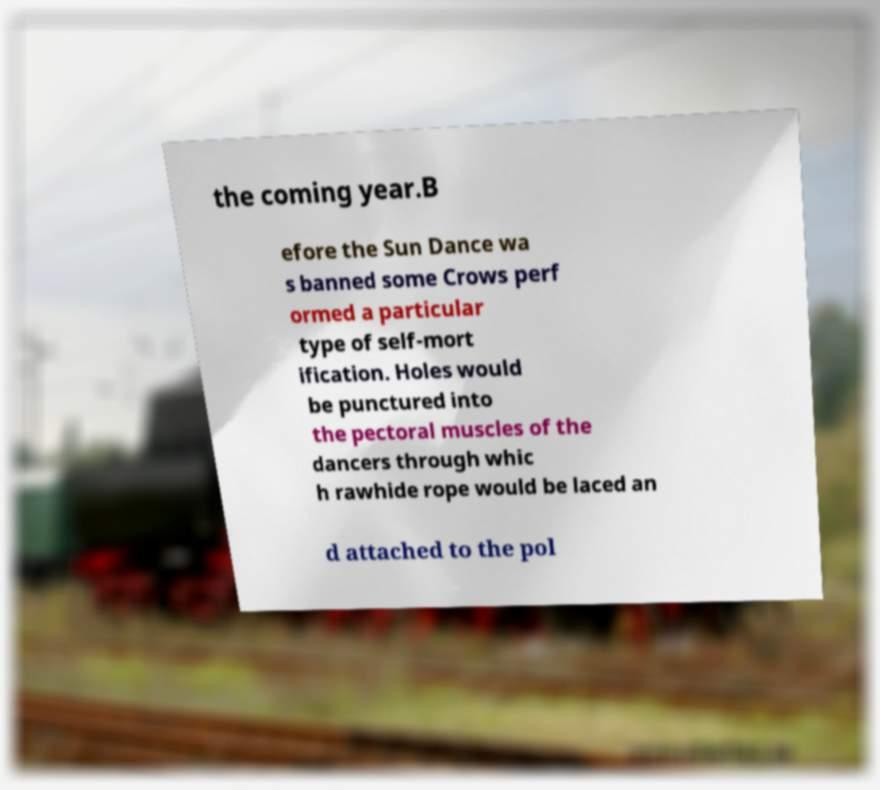What messages or text are displayed in this image? I need them in a readable, typed format. the coming year.B efore the Sun Dance wa s banned some Crows perf ormed a particular type of self-mort ification. Holes would be punctured into the pectoral muscles of the dancers through whic h rawhide rope would be laced an d attached to the pol 